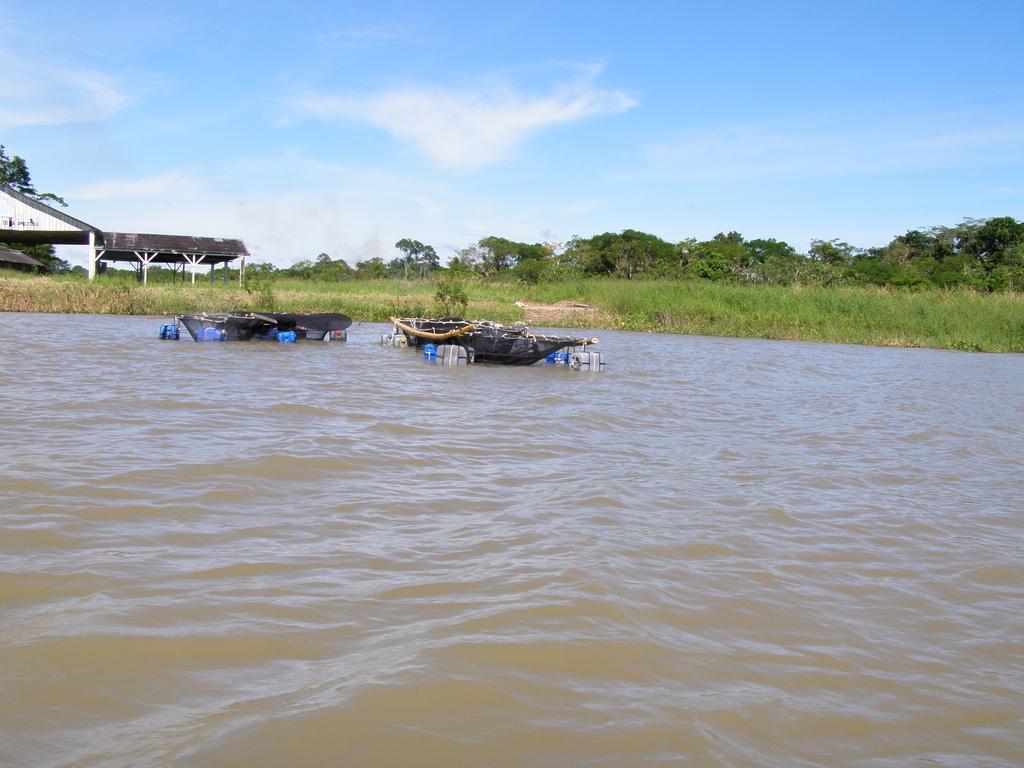Could you give a brief overview of what you see in this image? In this image I can see two boats on the water. In the background I can see the shed, few trees in green color and the sky is in white and blue color. 